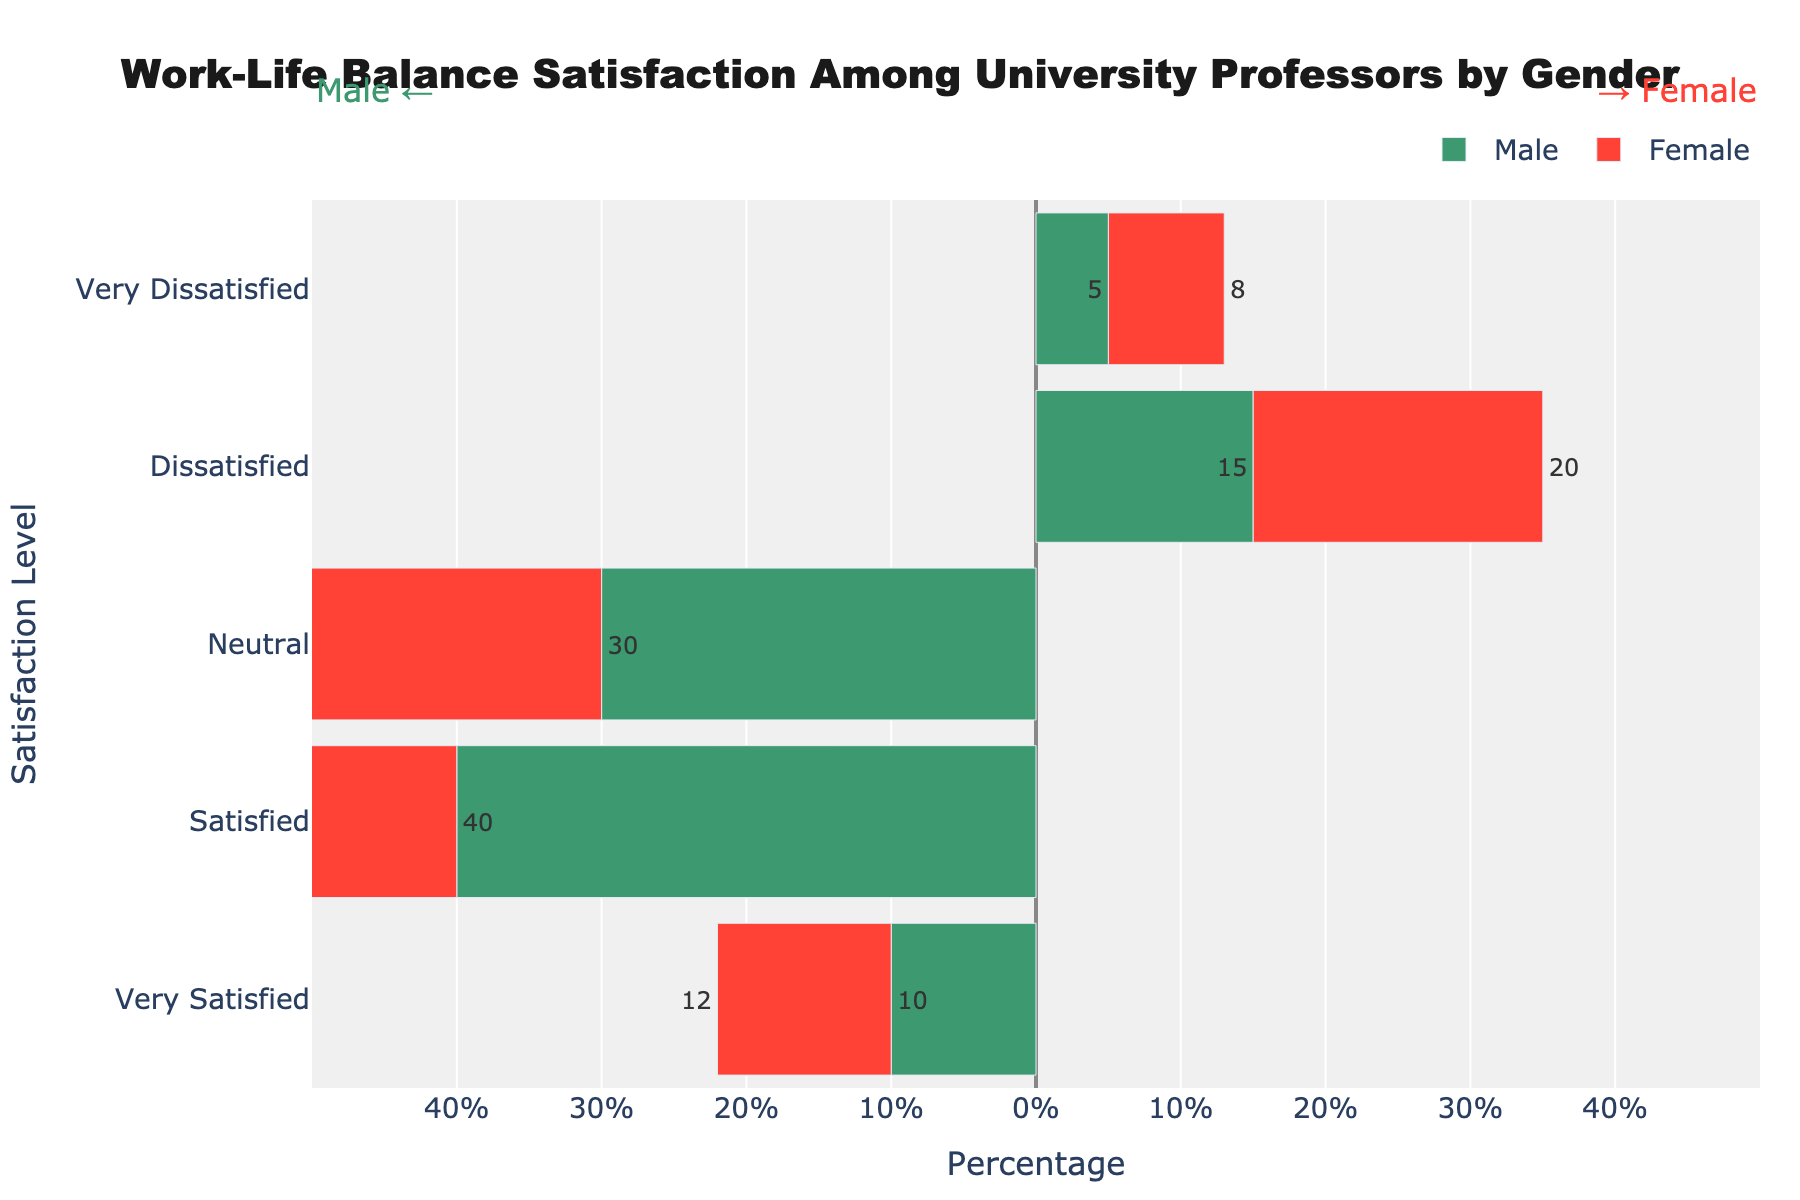What is the total number of male professors who are either satisfied or very satisfied with their work-life balance? For male professors, the number satisfied is 40 and very satisfied is 10. Adding these together: 40 + 10 = 50
Answer: 50 Which gender has a higher number of professors who are very dissatisfied with their work-life balance? For very dissatisfied, males have 5 and females have 8. Comparing these values, 8 > 5, so females have a higher number of very dissatisfied professors.
Answer: Female What is the difference in the number of neutral responses between male and female professors? Male professors have 30 neutral responses and female professors have 25. Subtracting these: 30 - 25 = 5
Answer: 5 How many female professors are either dissatisfied or neutral with their work-life balance? For female professors, the number dissatisfied is 20 and neutral is 25. Adding these together: 20 + 25 = 45
Answer: 45 Which satisfaction level shows the smallest difference in the number of responses between genders? Calculate the differences: Very Dissatisfied (8-5=3), Dissatisfied (20-15=5), Neutral (30-25=5), Satisfied (40-35=5), Very Satisfied (12-10=2). The smallest difference is 2, for very satisfied.
Answer: Very Satisfied Between satisfied and very satisfied levels, which gender has more responses in total? For males: satisfied + very satisfied = 40 + 10 = 50. For females: satisfied + very satisfied = 35 + 12 = 47. Comparing these, 50 > 47, so males have more responses.
Answer: Male Which category has the largest number of responses overall when combining both genders? Summing each category: Very Dissatisfied (5+8=13), Dissatisfied (15+20=35), Neutral (30+25=55), Satisfied (40+35=75), Very Satisfied (10+12=22). The largest number is in the "Satisfied" category with 75 responses.
Answer: Satisfied What percentage of the total responses for male professors does the very dissatisfied category represent? Total responses for male professors: 5 + 15 + 30 + 40 + 10 = 100. Very Dissatisfied responses: 5. Percentage: (5/100) * 100% = 5%
Answer: 5% What is the combined number of professors (male and female) who are dissatisfied with their work-life balance? Male professors have 15 dissatisfied, and female professors have 20 dissatisfied. Adding these together: 15 + 20 = 35
Answer: 35 How many total responses are recorded for male and female professors combined across all satisfaction levels? Total for males: 100. Total for females: 100. Combined total: 100 + 100 = 200
Answer: 200 